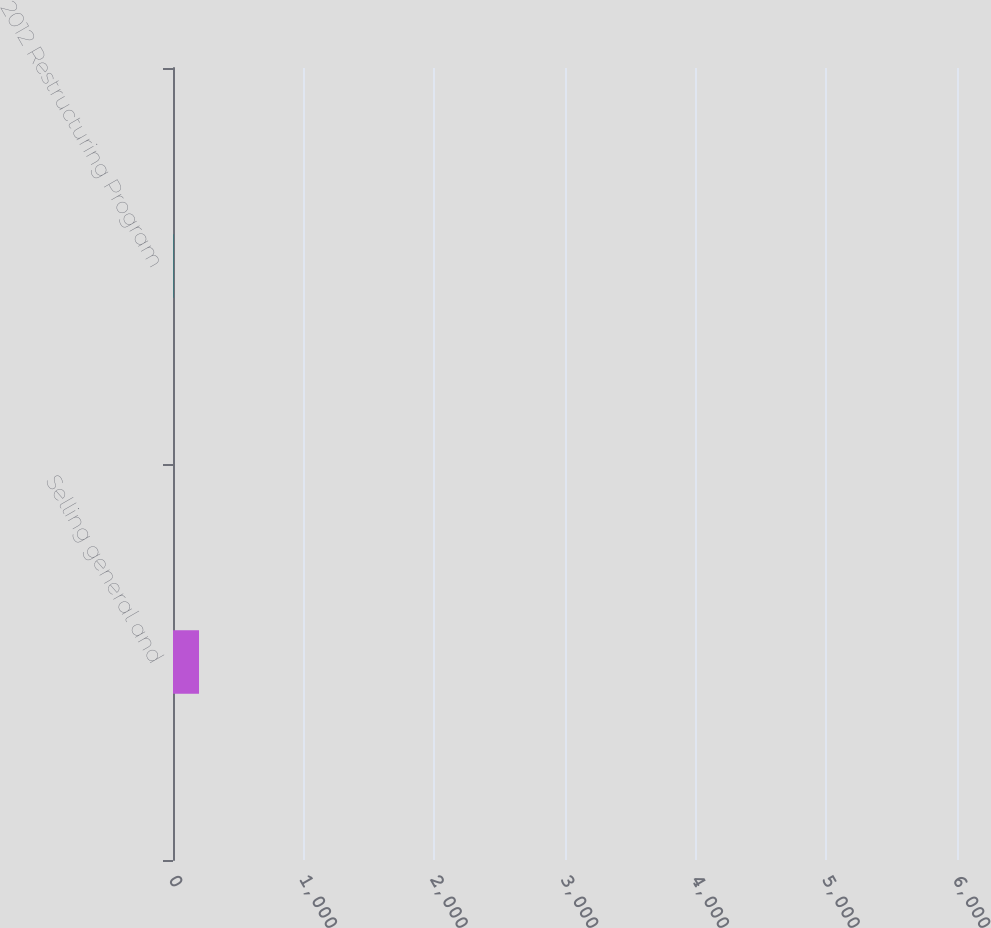Convert chart. <chart><loc_0><loc_0><loc_500><loc_500><bar_chart><fcel>Selling general and<fcel>2012 Restructuring Program<nl><fcel>5172<fcel>77<nl></chart> 